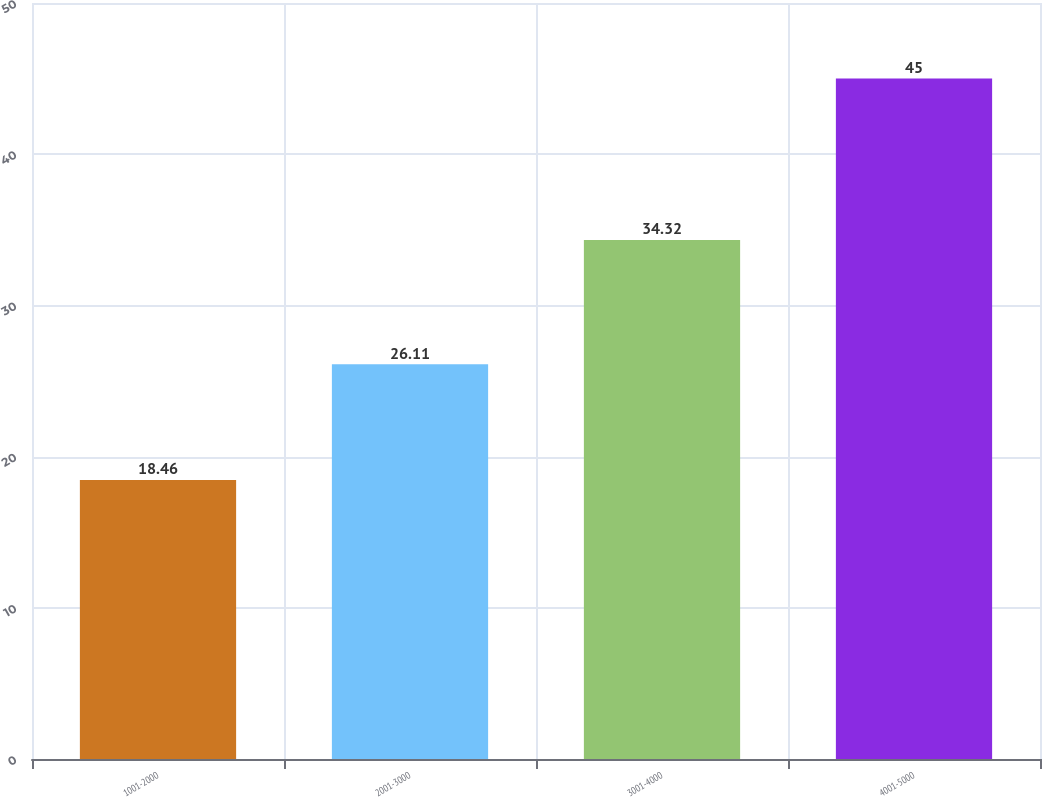<chart> <loc_0><loc_0><loc_500><loc_500><bar_chart><fcel>1001-2000<fcel>2001-3000<fcel>3001-4000<fcel>4001-5000<nl><fcel>18.46<fcel>26.11<fcel>34.32<fcel>45<nl></chart> 